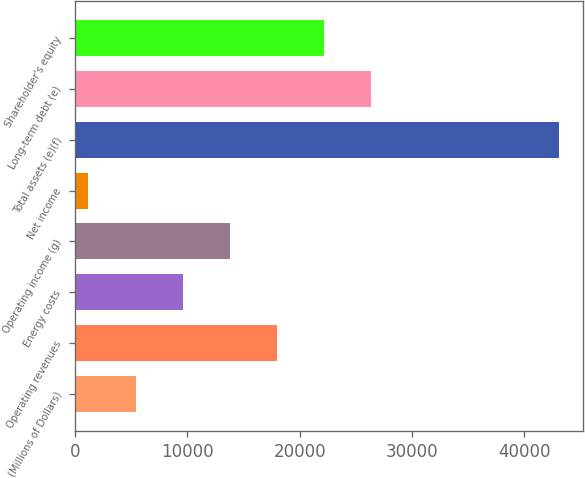<chart> <loc_0><loc_0><loc_500><loc_500><bar_chart><fcel>(Millions of Dollars)<fcel>Operating revenues<fcel>Energy costs<fcel>Operating income (g)<fcel>Net income<fcel>Total assets (e)(f)<fcel>Long-term debt (e)<fcel>Shareholder's equity<nl><fcel>5387.2<fcel>17960.8<fcel>9578.4<fcel>13769.6<fcel>1196<fcel>43108<fcel>26343.2<fcel>22152<nl></chart> 